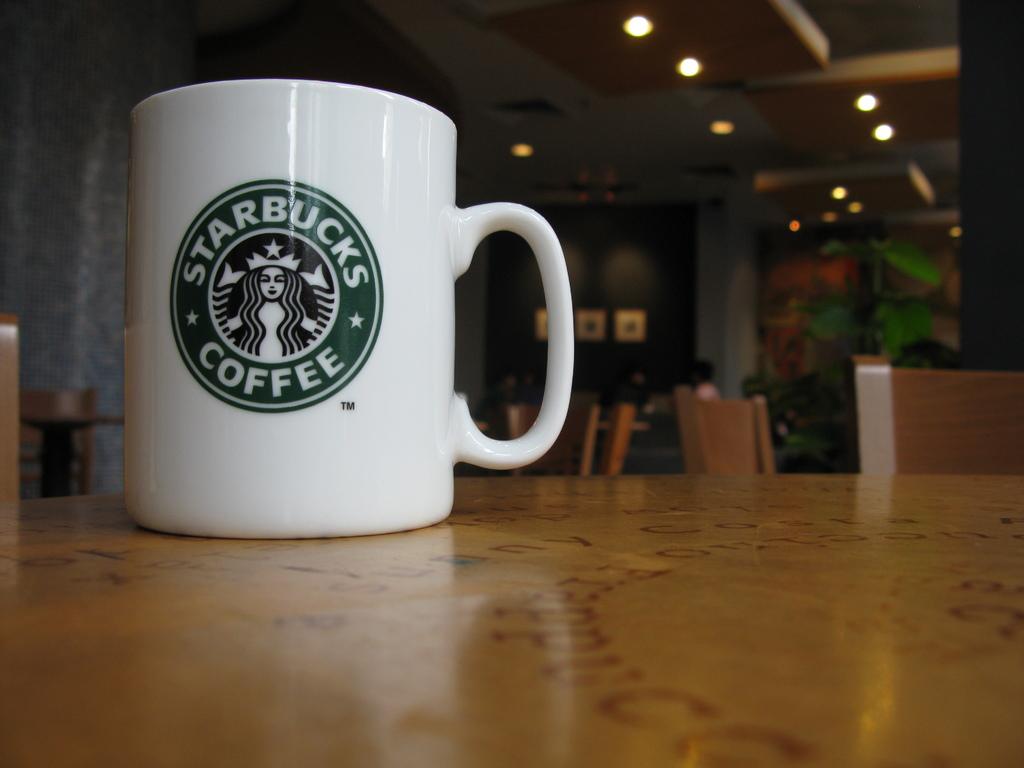Where is the mug from?
Offer a very short reply. Starbucks. What does the company sell?
Offer a very short reply. Coffee. 